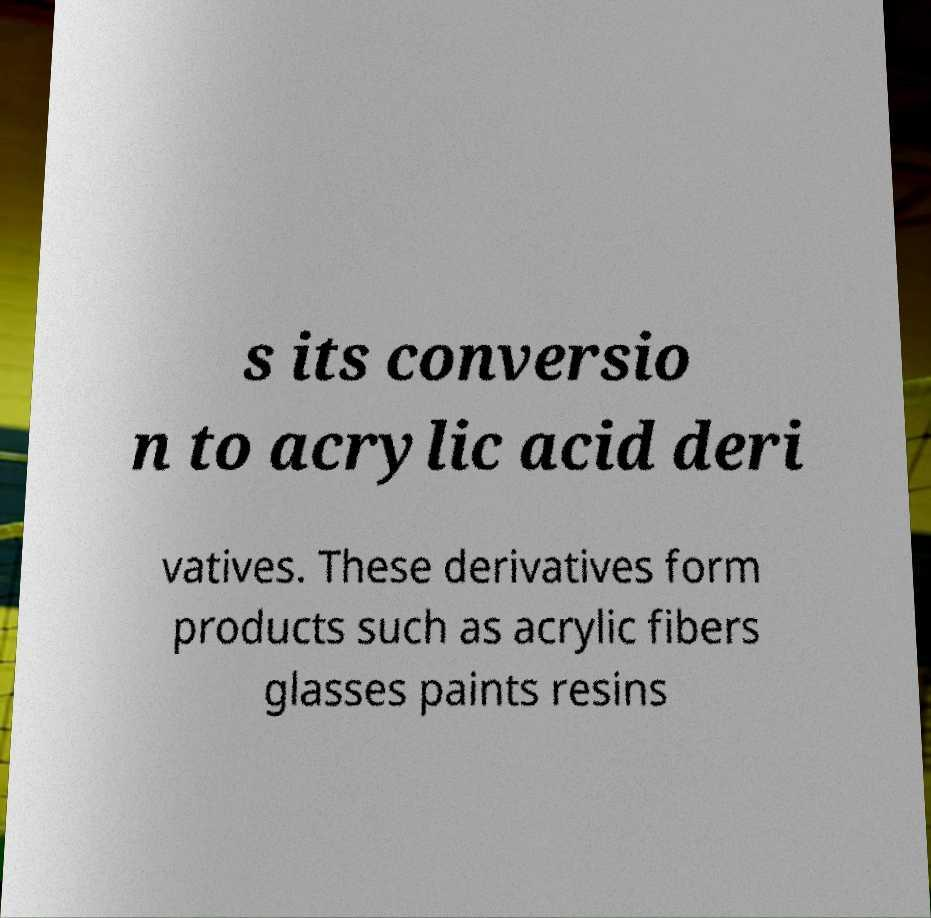What messages or text are displayed in this image? I need them in a readable, typed format. s its conversio n to acrylic acid deri vatives. These derivatives form products such as acrylic fibers glasses paints resins 